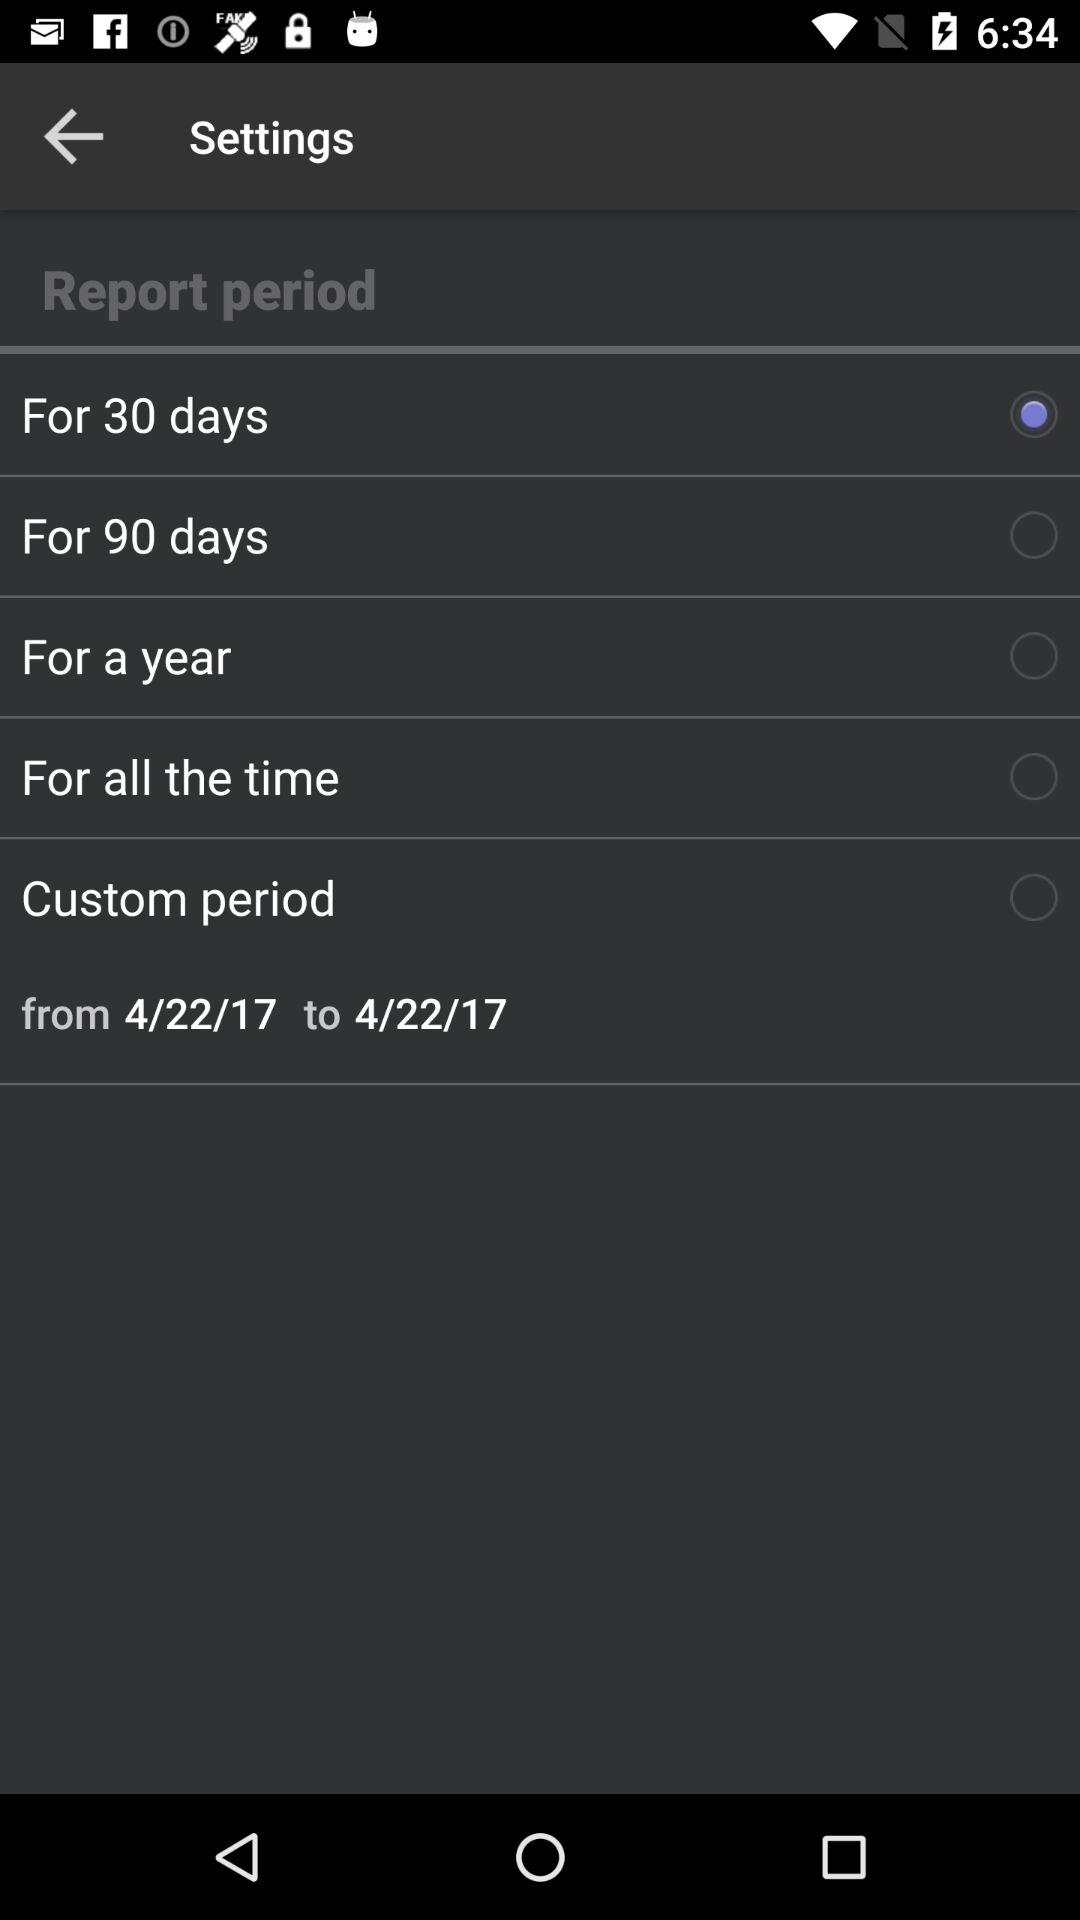How many notifications are there in "Settings"?
When the provided information is insufficient, respond with <no answer>. <no answer> 